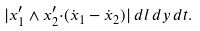<formula> <loc_0><loc_0><loc_500><loc_500>| { x } _ { 1 } ^ { \prime } \wedge { x } _ { 2 } ^ { \prime } { \cdot } ( \dot { x } _ { 1 } - \dot { x } _ { 2 } ) | \, d l \, d y \, d t .</formula> 